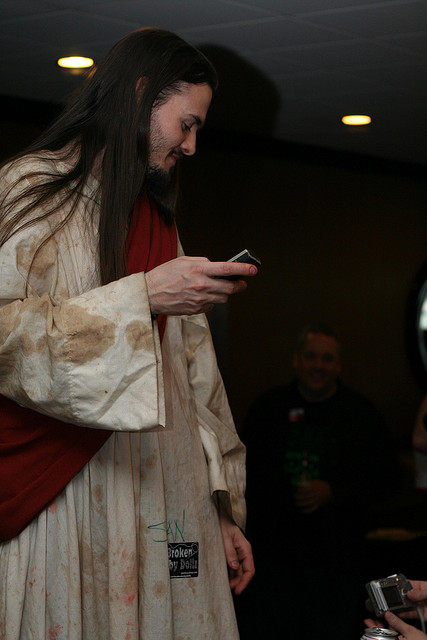<image>Who is this man dressed as? I do not know who this man is dressed as. The responses range from 'jesus' to 'woman'. Who is this man dressed as? I don't know who the man is dressed as. It can be Jesus or someone else. 